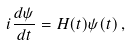<formula> <loc_0><loc_0><loc_500><loc_500>i \frac { d \psi } { d t } = H ( t ) \psi ( t ) \, ,</formula> 